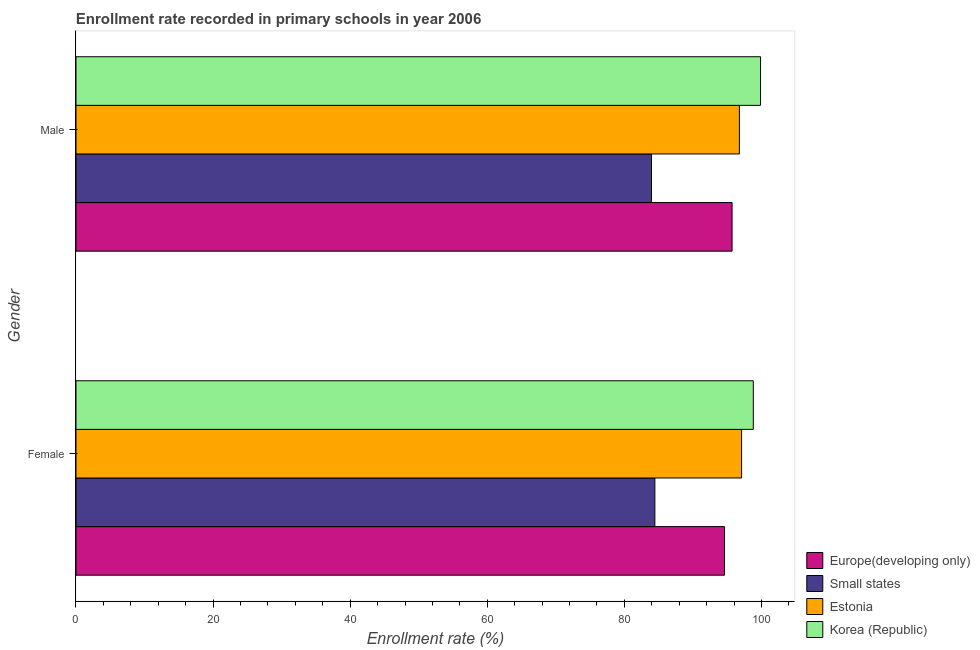How many different coloured bars are there?
Make the answer very short. 4. Are the number of bars on each tick of the Y-axis equal?
Provide a short and direct response. Yes. How many bars are there on the 2nd tick from the bottom?
Your answer should be very brief. 4. What is the enrollment rate of female students in Korea (Republic)?
Offer a very short reply. 98.81. Across all countries, what is the maximum enrollment rate of male students?
Ensure brevity in your answer.  99.87. Across all countries, what is the minimum enrollment rate of female students?
Provide a succinct answer. 84.45. In which country was the enrollment rate of female students minimum?
Make the answer very short. Small states. What is the total enrollment rate of male students in the graph?
Offer a terse response. 376.31. What is the difference between the enrollment rate of male students in Estonia and that in Korea (Republic)?
Your answer should be compact. -3.09. What is the difference between the enrollment rate of male students in Europe(developing only) and the enrollment rate of female students in Small states?
Offer a very short reply. 11.26. What is the average enrollment rate of male students per country?
Offer a terse response. 94.08. What is the difference between the enrollment rate of male students and enrollment rate of female students in Korea (Republic)?
Your answer should be compact. 1.06. In how many countries, is the enrollment rate of female students greater than 76 %?
Offer a very short reply. 4. What is the ratio of the enrollment rate of male students in Korea (Republic) to that in Estonia?
Give a very brief answer. 1.03. In how many countries, is the enrollment rate of female students greater than the average enrollment rate of female students taken over all countries?
Offer a terse response. 3. What does the 4th bar from the top in Male represents?
Give a very brief answer. Europe(developing only). What does the 3rd bar from the bottom in Female represents?
Offer a very short reply. Estonia. How many bars are there?
Give a very brief answer. 8. Are all the bars in the graph horizontal?
Keep it short and to the point. Yes. How many countries are there in the graph?
Ensure brevity in your answer.  4. What is the difference between two consecutive major ticks on the X-axis?
Make the answer very short. 20. Does the graph contain any zero values?
Ensure brevity in your answer.  No. Where does the legend appear in the graph?
Keep it short and to the point. Bottom right. What is the title of the graph?
Your response must be concise. Enrollment rate recorded in primary schools in year 2006. What is the label or title of the X-axis?
Provide a short and direct response. Enrollment rate (%). What is the label or title of the Y-axis?
Give a very brief answer. Gender. What is the Enrollment rate (%) of Europe(developing only) in Female?
Ensure brevity in your answer.  94.61. What is the Enrollment rate (%) of Small states in Female?
Your answer should be compact. 84.45. What is the Enrollment rate (%) of Estonia in Female?
Offer a terse response. 97.1. What is the Enrollment rate (%) of Korea (Republic) in Female?
Provide a succinct answer. 98.81. What is the Enrollment rate (%) of Europe(developing only) in Male?
Give a very brief answer. 95.71. What is the Enrollment rate (%) in Small states in Male?
Your response must be concise. 83.95. What is the Enrollment rate (%) in Estonia in Male?
Offer a terse response. 96.78. What is the Enrollment rate (%) of Korea (Republic) in Male?
Your answer should be compact. 99.87. Across all Gender, what is the maximum Enrollment rate (%) of Europe(developing only)?
Keep it short and to the point. 95.71. Across all Gender, what is the maximum Enrollment rate (%) of Small states?
Give a very brief answer. 84.45. Across all Gender, what is the maximum Enrollment rate (%) of Estonia?
Ensure brevity in your answer.  97.1. Across all Gender, what is the maximum Enrollment rate (%) in Korea (Republic)?
Provide a short and direct response. 99.87. Across all Gender, what is the minimum Enrollment rate (%) in Europe(developing only)?
Keep it short and to the point. 94.61. Across all Gender, what is the minimum Enrollment rate (%) in Small states?
Offer a terse response. 83.95. Across all Gender, what is the minimum Enrollment rate (%) in Estonia?
Give a very brief answer. 96.78. Across all Gender, what is the minimum Enrollment rate (%) of Korea (Republic)?
Make the answer very short. 98.81. What is the total Enrollment rate (%) in Europe(developing only) in the graph?
Keep it short and to the point. 190.32. What is the total Enrollment rate (%) of Small states in the graph?
Give a very brief answer. 168.4. What is the total Enrollment rate (%) in Estonia in the graph?
Offer a very short reply. 193.88. What is the total Enrollment rate (%) of Korea (Republic) in the graph?
Your answer should be very brief. 198.67. What is the difference between the Enrollment rate (%) in Europe(developing only) in Female and that in Male?
Make the answer very short. -1.1. What is the difference between the Enrollment rate (%) in Small states in Female and that in Male?
Provide a succinct answer. 0.5. What is the difference between the Enrollment rate (%) in Estonia in Female and that in Male?
Your answer should be very brief. 0.32. What is the difference between the Enrollment rate (%) of Korea (Republic) in Female and that in Male?
Ensure brevity in your answer.  -1.06. What is the difference between the Enrollment rate (%) of Europe(developing only) in Female and the Enrollment rate (%) of Small states in Male?
Your response must be concise. 10.66. What is the difference between the Enrollment rate (%) in Europe(developing only) in Female and the Enrollment rate (%) in Estonia in Male?
Provide a short and direct response. -2.17. What is the difference between the Enrollment rate (%) in Europe(developing only) in Female and the Enrollment rate (%) in Korea (Republic) in Male?
Give a very brief answer. -5.25. What is the difference between the Enrollment rate (%) of Small states in Female and the Enrollment rate (%) of Estonia in Male?
Ensure brevity in your answer.  -12.33. What is the difference between the Enrollment rate (%) of Small states in Female and the Enrollment rate (%) of Korea (Republic) in Male?
Your response must be concise. -15.42. What is the difference between the Enrollment rate (%) of Estonia in Female and the Enrollment rate (%) of Korea (Republic) in Male?
Your answer should be compact. -2.76. What is the average Enrollment rate (%) in Europe(developing only) per Gender?
Offer a terse response. 95.16. What is the average Enrollment rate (%) in Small states per Gender?
Ensure brevity in your answer.  84.2. What is the average Enrollment rate (%) of Estonia per Gender?
Ensure brevity in your answer.  96.94. What is the average Enrollment rate (%) of Korea (Republic) per Gender?
Your answer should be compact. 99.34. What is the difference between the Enrollment rate (%) in Europe(developing only) and Enrollment rate (%) in Small states in Female?
Ensure brevity in your answer.  10.16. What is the difference between the Enrollment rate (%) in Europe(developing only) and Enrollment rate (%) in Estonia in Female?
Offer a very short reply. -2.49. What is the difference between the Enrollment rate (%) in Europe(developing only) and Enrollment rate (%) in Korea (Republic) in Female?
Provide a short and direct response. -4.2. What is the difference between the Enrollment rate (%) in Small states and Enrollment rate (%) in Estonia in Female?
Offer a very short reply. -12.65. What is the difference between the Enrollment rate (%) of Small states and Enrollment rate (%) of Korea (Republic) in Female?
Keep it short and to the point. -14.36. What is the difference between the Enrollment rate (%) of Estonia and Enrollment rate (%) of Korea (Republic) in Female?
Your answer should be compact. -1.71. What is the difference between the Enrollment rate (%) of Europe(developing only) and Enrollment rate (%) of Small states in Male?
Keep it short and to the point. 11.76. What is the difference between the Enrollment rate (%) in Europe(developing only) and Enrollment rate (%) in Estonia in Male?
Offer a very short reply. -1.07. What is the difference between the Enrollment rate (%) in Europe(developing only) and Enrollment rate (%) in Korea (Republic) in Male?
Provide a succinct answer. -4.15. What is the difference between the Enrollment rate (%) of Small states and Enrollment rate (%) of Estonia in Male?
Your answer should be compact. -12.83. What is the difference between the Enrollment rate (%) in Small states and Enrollment rate (%) in Korea (Republic) in Male?
Offer a very short reply. -15.92. What is the difference between the Enrollment rate (%) in Estonia and Enrollment rate (%) in Korea (Republic) in Male?
Your response must be concise. -3.09. What is the ratio of the Enrollment rate (%) in Europe(developing only) in Female to that in Male?
Your answer should be compact. 0.99. What is the ratio of the Enrollment rate (%) of Small states in Female to that in Male?
Ensure brevity in your answer.  1.01. What is the ratio of the Enrollment rate (%) of Korea (Republic) in Female to that in Male?
Ensure brevity in your answer.  0.99. What is the difference between the highest and the second highest Enrollment rate (%) in Europe(developing only)?
Offer a very short reply. 1.1. What is the difference between the highest and the second highest Enrollment rate (%) of Small states?
Offer a very short reply. 0.5. What is the difference between the highest and the second highest Enrollment rate (%) in Estonia?
Offer a terse response. 0.32. What is the difference between the highest and the second highest Enrollment rate (%) of Korea (Republic)?
Your answer should be compact. 1.06. What is the difference between the highest and the lowest Enrollment rate (%) of Europe(developing only)?
Your response must be concise. 1.1. What is the difference between the highest and the lowest Enrollment rate (%) of Small states?
Your answer should be very brief. 0.5. What is the difference between the highest and the lowest Enrollment rate (%) of Estonia?
Your answer should be very brief. 0.32. What is the difference between the highest and the lowest Enrollment rate (%) of Korea (Republic)?
Offer a terse response. 1.06. 